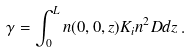<formula> <loc_0><loc_0><loc_500><loc_500>\gamma = \int _ { 0 } ^ { L } n ( 0 , 0 , z ) K _ { i } n ^ { 2 } D d z \, .</formula> 